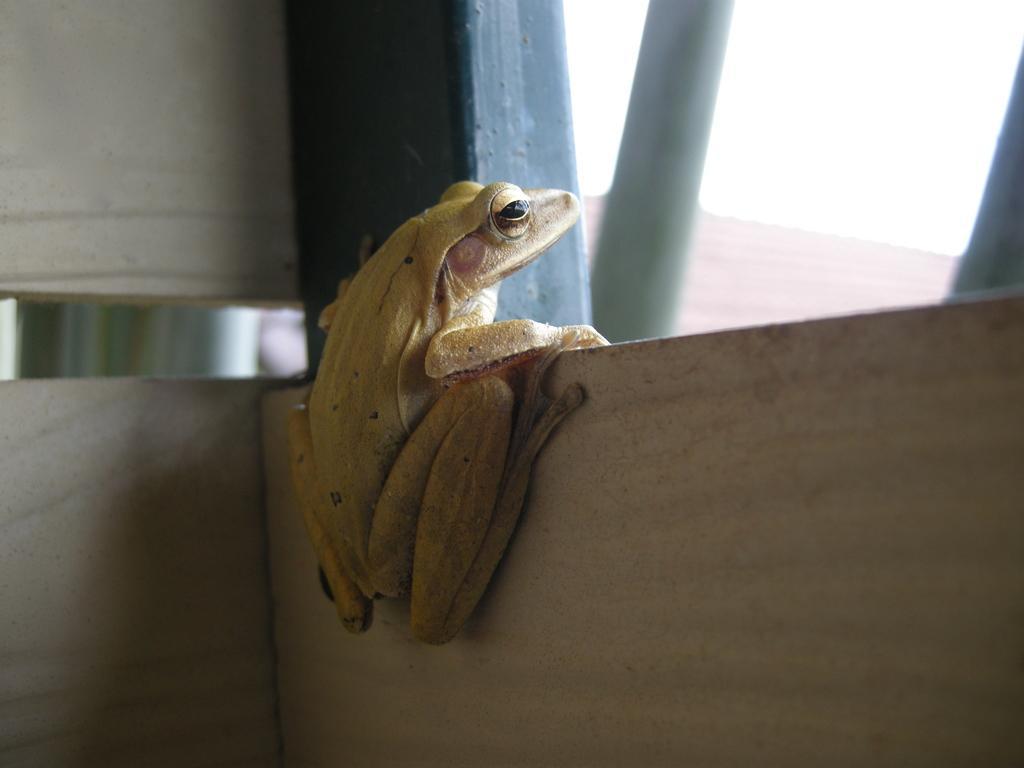How would you summarize this image in a sentence or two? In this picture we can see a sky and it looks like a sunny day. Here we can see a frog sitting on the wall and looking towards the sky. 